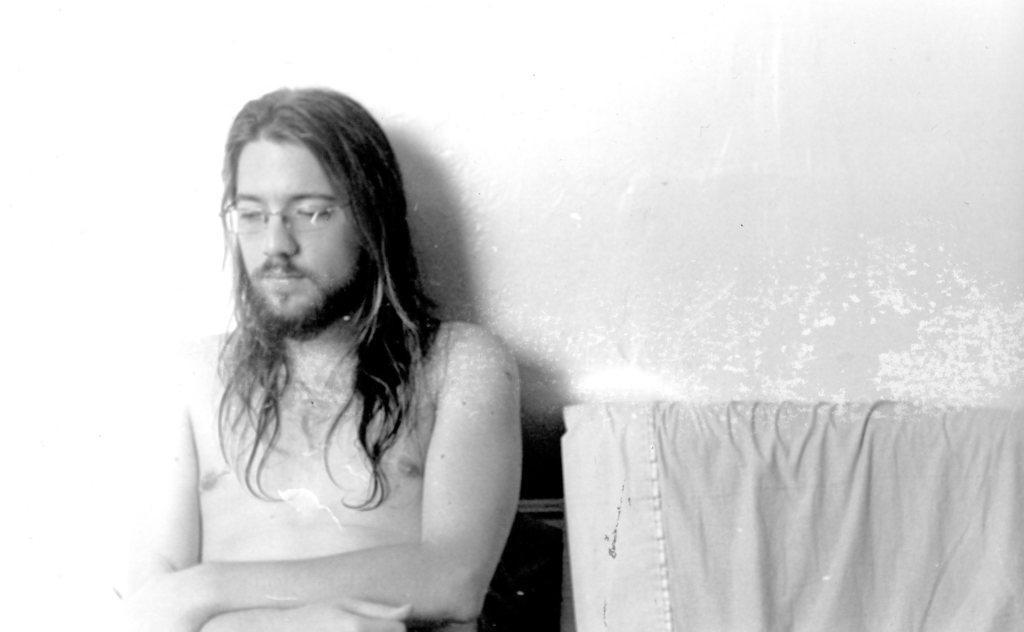Describe this image in one or two sentences. It is the black and white image in which there is a man who is sitting without the shirt. Beside him there is a cloth. In the background there is the wall. 